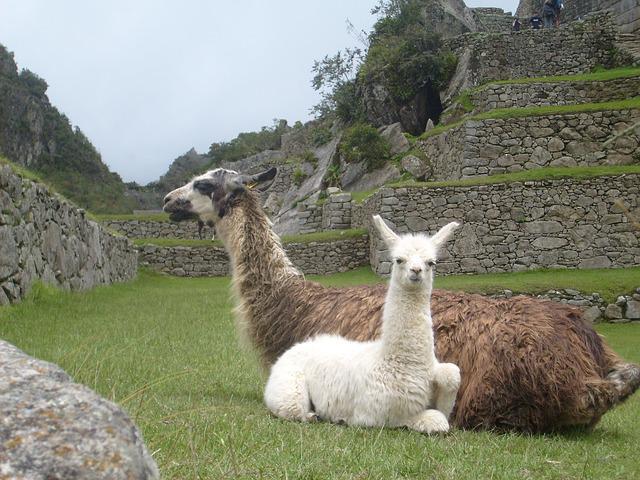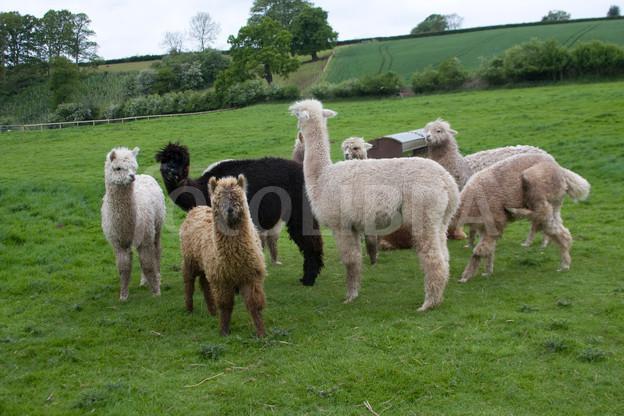The first image is the image on the left, the second image is the image on the right. Considering the images on both sides, is "In the image to the right, there are fewer than ten llamas." valid? Answer yes or no. Yes. The first image is the image on the left, the second image is the image on the right. Examine the images to the left and right. Is the description "Each image includes at least four llamas, and no image shows a group of forward-facing llamas." accurate? Answer yes or no. No. 